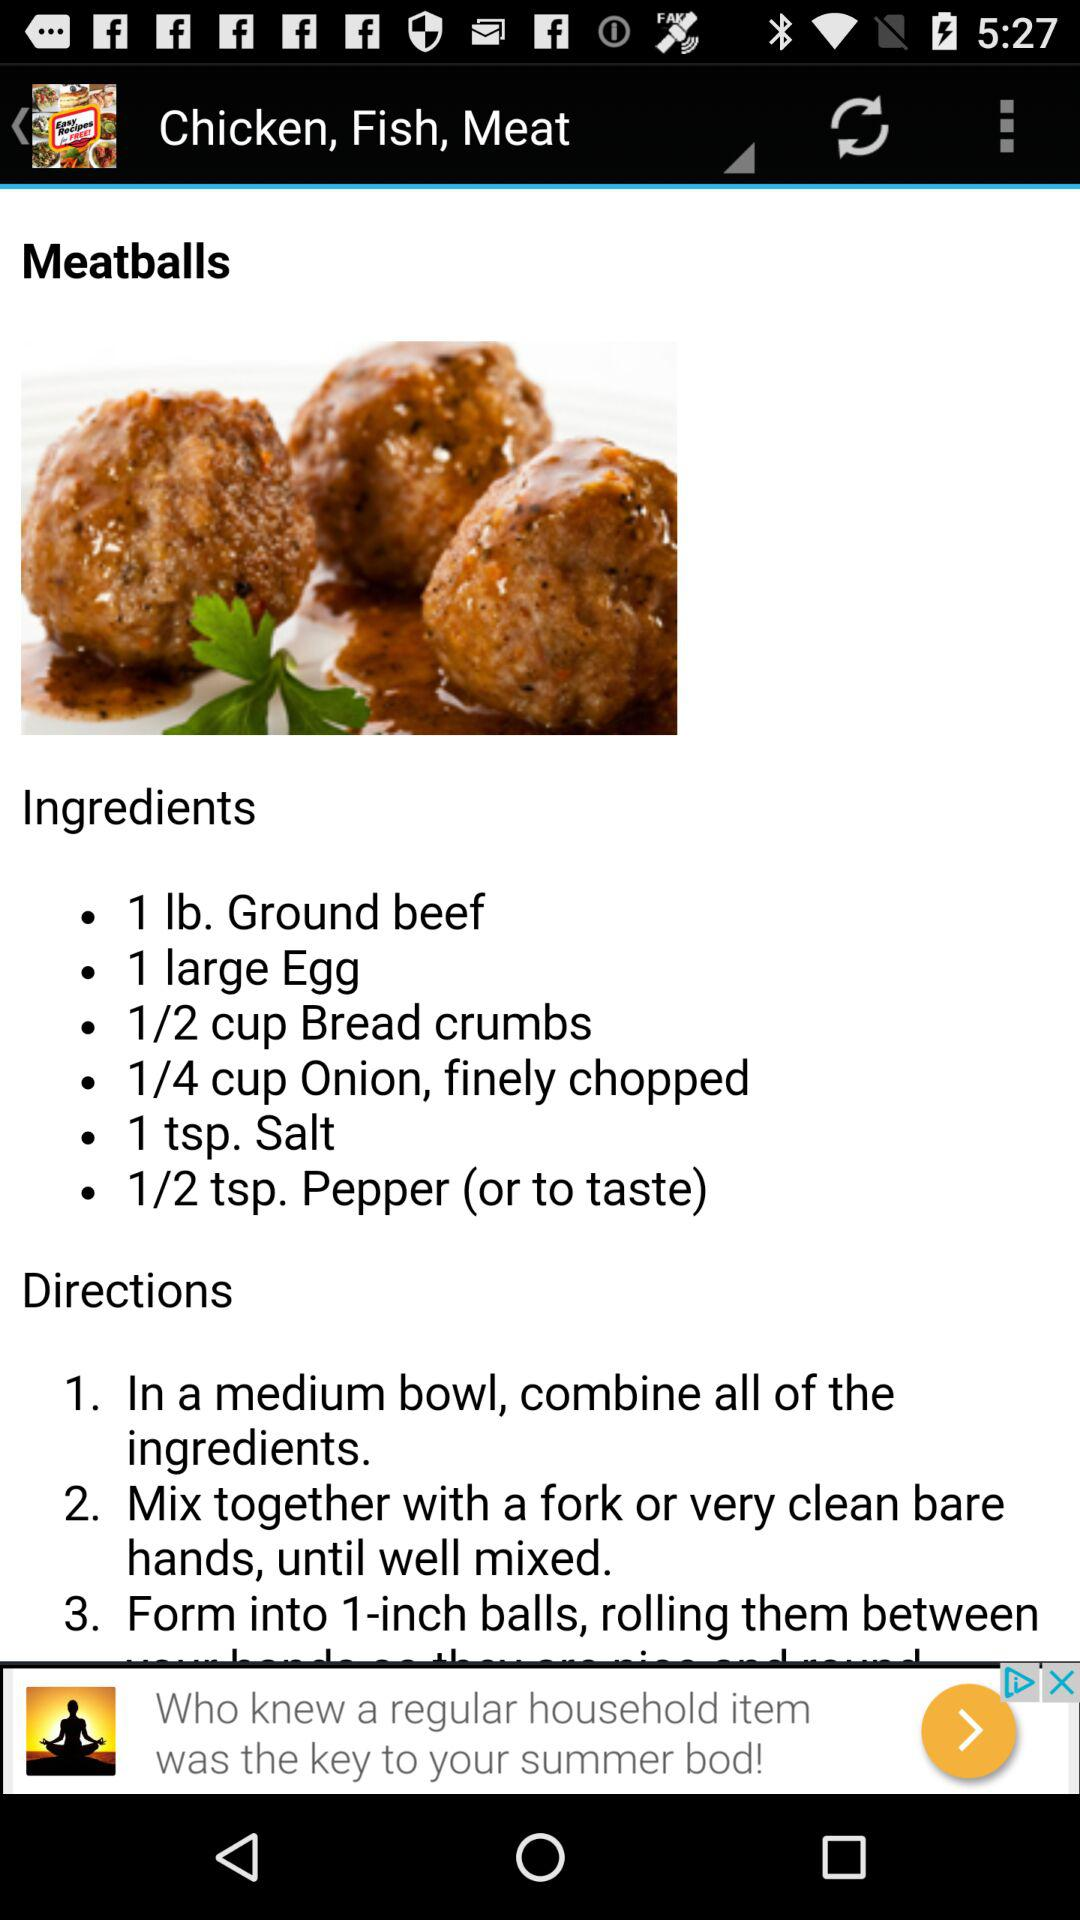What is the name of the dish? The name of the dish is "Meatballs". 